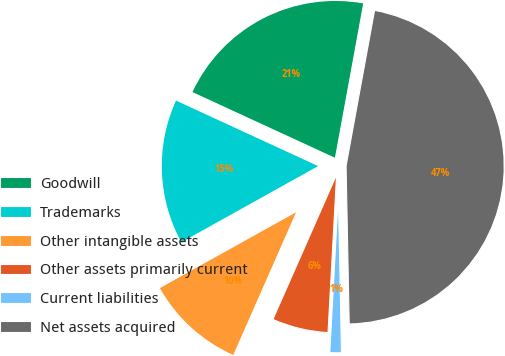<chart> <loc_0><loc_0><loc_500><loc_500><pie_chart><fcel>Goodwill<fcel>Trademarks<fcel>Other intangible assets<fcel>Other assets primarily current<fcel>Current liabilities<fcel>Net assets acquired<nl><fcel>21.01%<fcel>14.96%<fcel>10.31%<fcel>5.74%<fcel>1.18%<fcel>46.8%<nl></chart> 